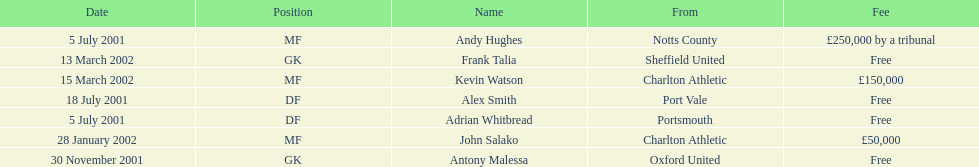Which transfer in was next after john salako's in 2002? Frank Talia. 